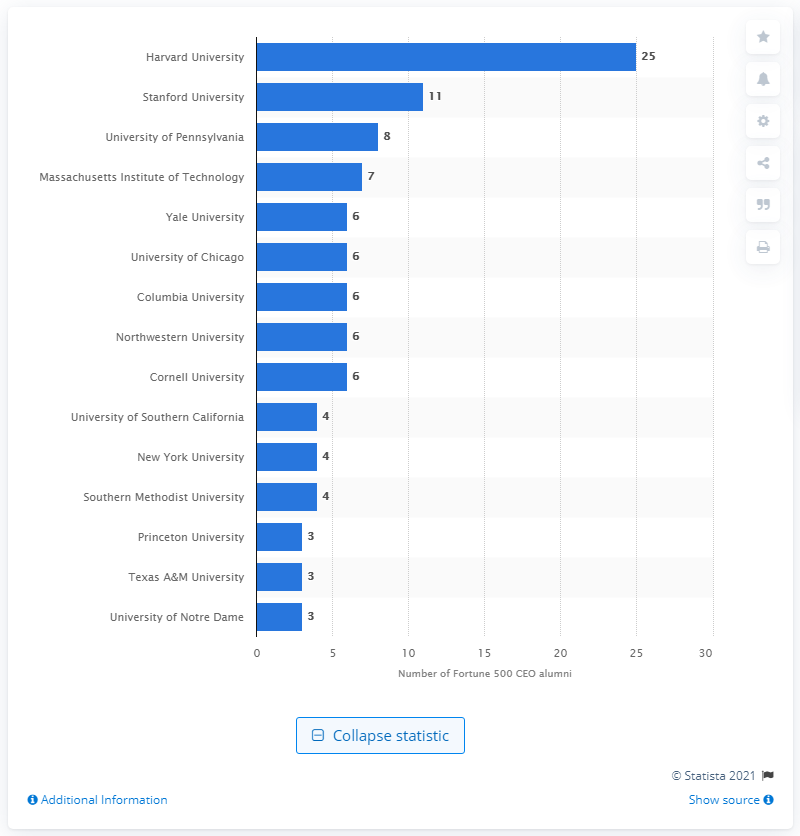Give some essential details in this illustration. In 2020, 25 alumni of Harvard served as CEOs of companies listed on the Fortune 500 list. 